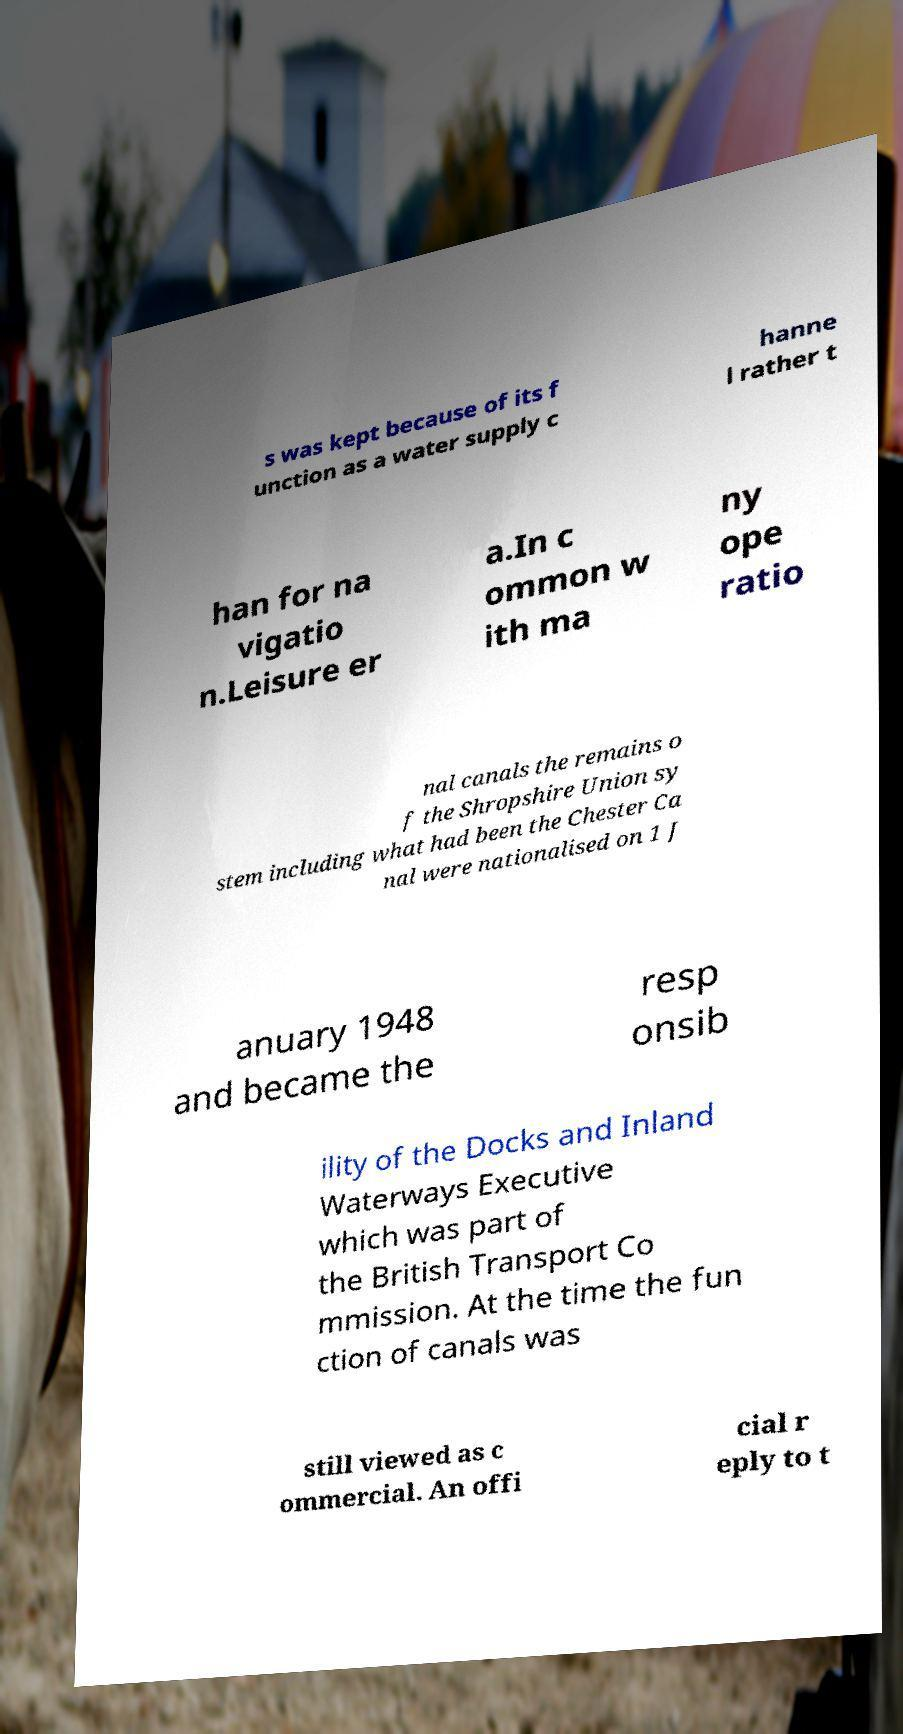There's text embedded in this image that I need extracted. Can you transcribe it verbatim? s was kept because of its f unction as a water supply c hanne l rather t han for na vigatio n.Leisure er a.In c ommon w ith ma ny ope ratio nal canals the remains o f the Shropshire Union sy stem including what had been the Chester Ca nal were nationalised on 1 J anuary 1948 and became the resp onsib ility of the Docks and Inland Waterways Executive which was part of the British Transport Co mmission. At the time the fun ction of canals was still viewed as c ommercial. An offi cial r eply to t 